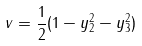<formula> <loc_0><loc_0><loc_500><loc_500>v = \frac { 1 } { 2 } ( 1 - y _ { 2 } ^ { 2 } - y _ { 3 } ^ { 2 } )</formula> 